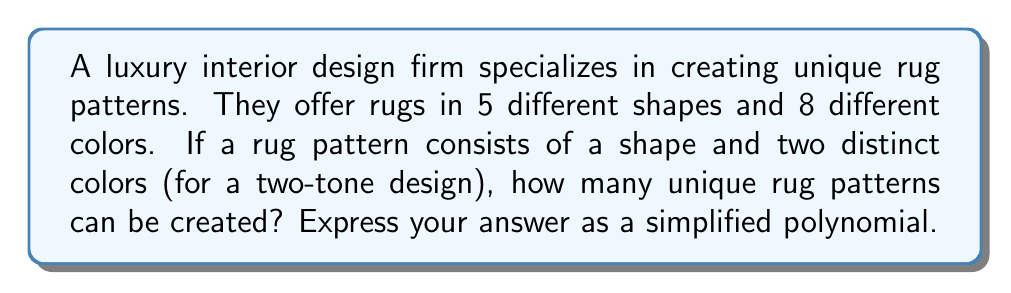What is the answer to this math problem? Let's approach this step-by-step:

1) First, we need to choose a shape for the rug:
   There are 5 shapes to choose from.

2) Next, we need to choose two distinct colors out of 8:
   This is a combination problem. We can calculate this using the formula:
   $$\binom{8}{2} = \frac{8!}{2!(8-2)!} = \frac{8!}{2!(6)!}$$

3) Let's calculate this:
   $$\frac{8 \cdot 7}{2 \cdot 1} = 28$$

4) Now, for each shape, we can create 28 different color combinations.
   Therefore, the total number of unique rug patterns is:

   $$5 \cdot 28$$

5) Simplifying:
   $$5 \cdot 28 = 140$$

Thus, the simplified polynomial expression for the number of unique rug patterns is 140.
Answer: 140 